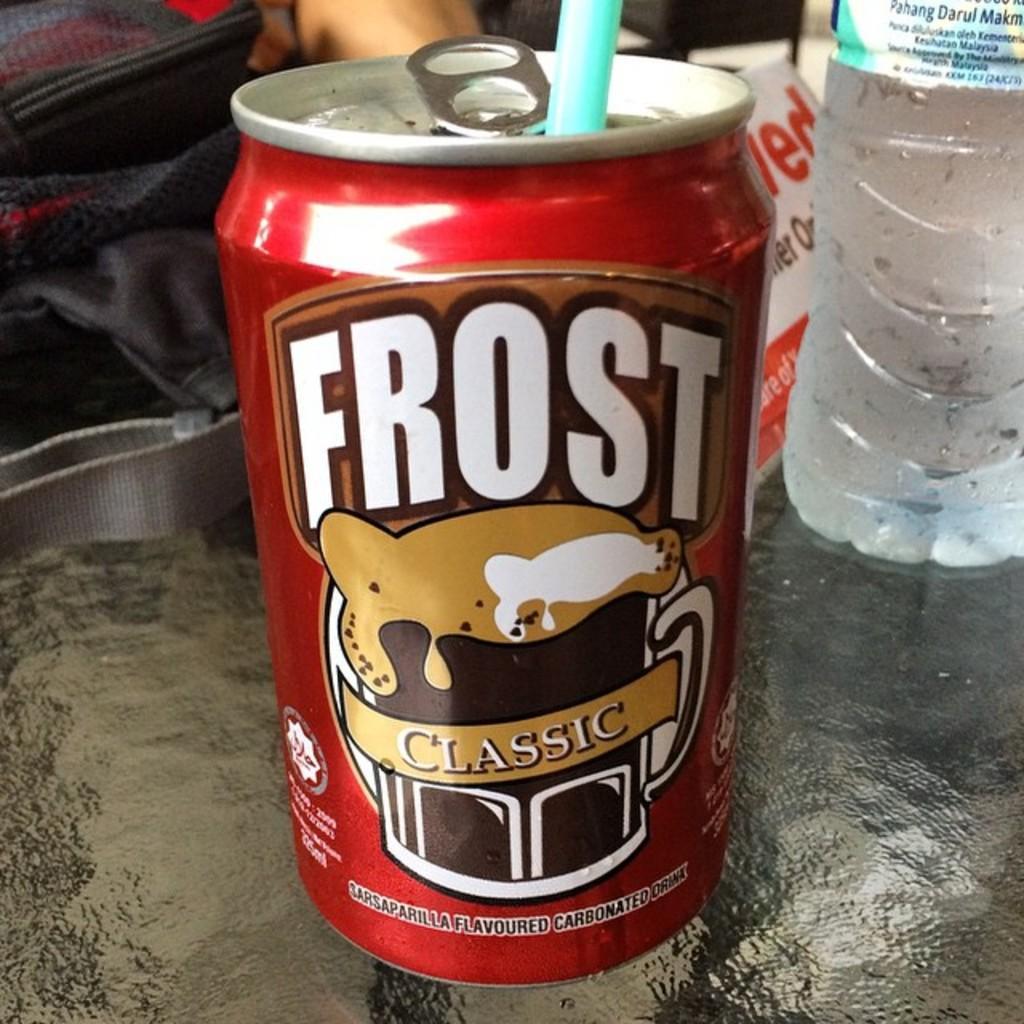How would you summarize this image in a sentence or two? This image is taken indoors. At the bottom of the image there is a table with a water bottle, a bag, a coke tin with straw and a board with a text on it. At the top of the image there is a person. 